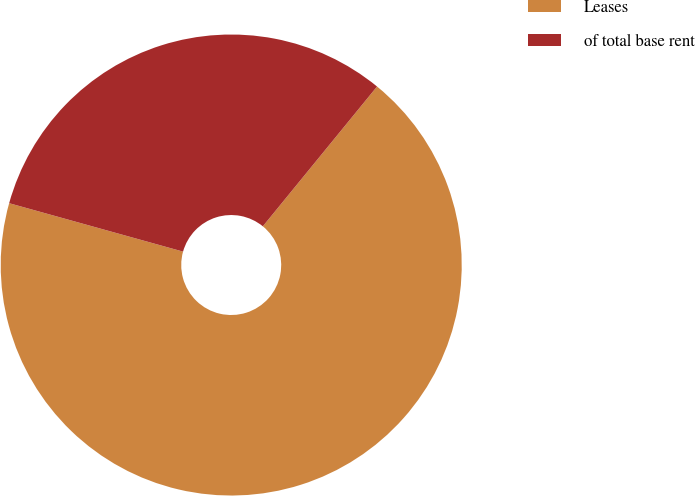Convert chart to OTSL. <chart><loc_0><loc_0><loc_500><loc_500><pie_chart><fcel>Leases<fcel>of total base rent<nl><fcel>68.42%<fcel>31.58%<nl></chart> 